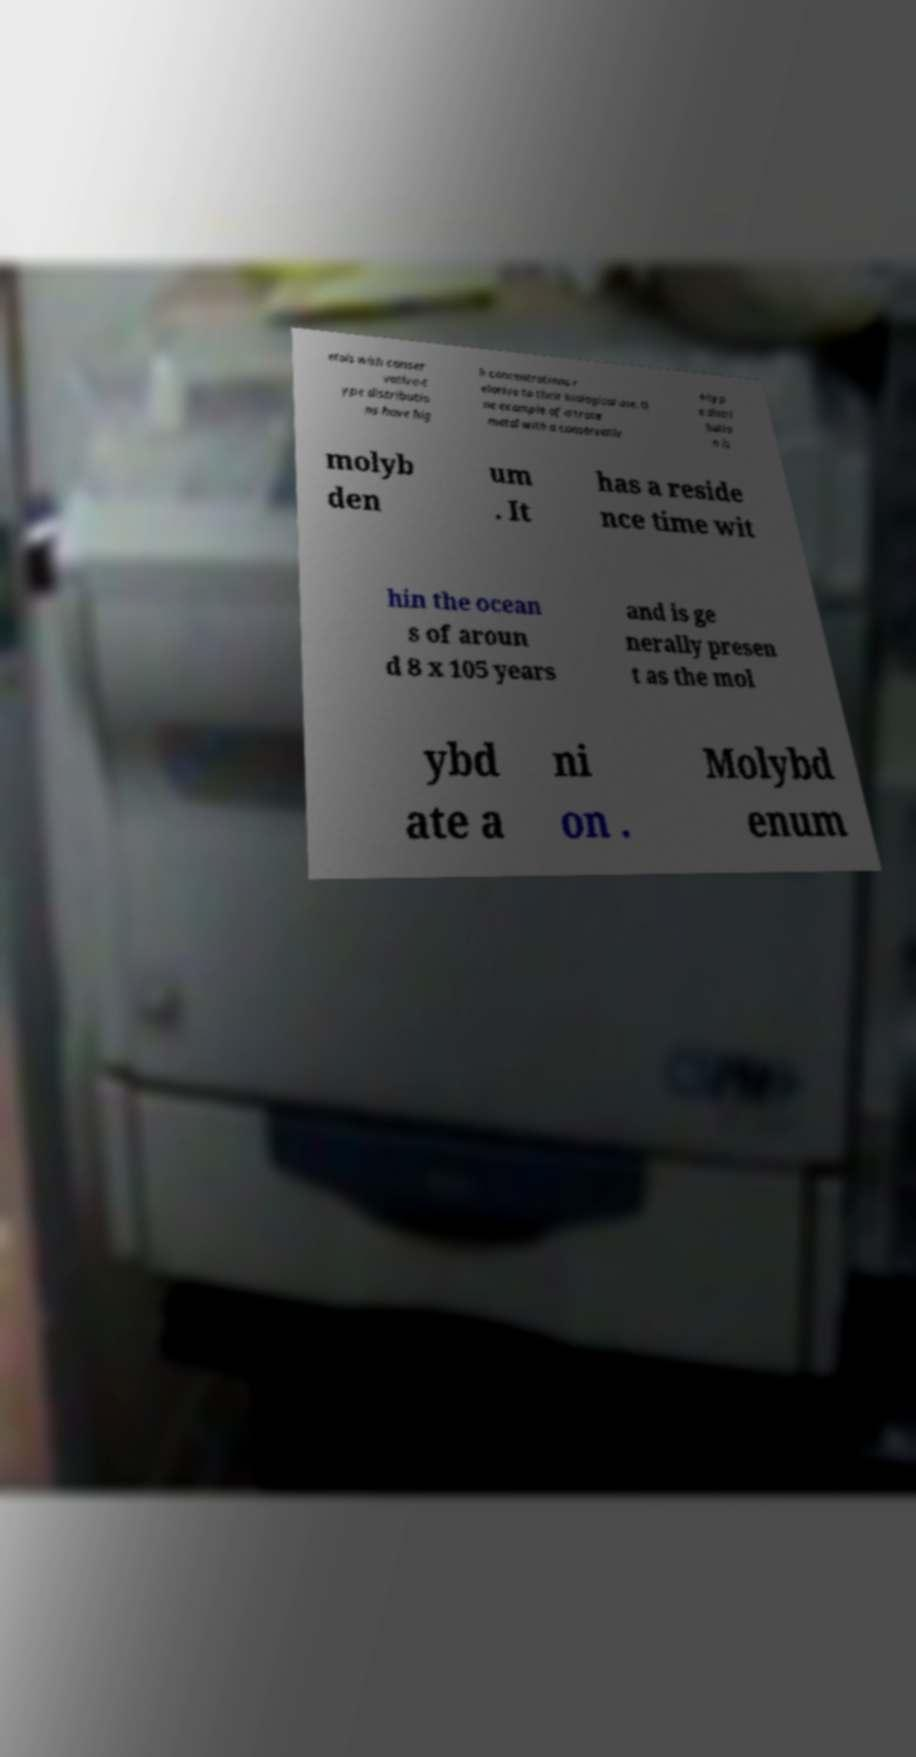Can you read and provide the text displayed in the image?This photo seems to have some interesting text. Can you extract and type it out for me? etals with conser vative-t ype distributio ns have hig h concentrations r elative to their biological use. O ne example of a trace metal with a conservativ e-typ e distri butio n is molyb den um . It has a reside nce time wit hin the ocean s of aroun d 8 x 105 years and is ge nerally presen t as the mol ybd ate a ni on . Molybd enum 